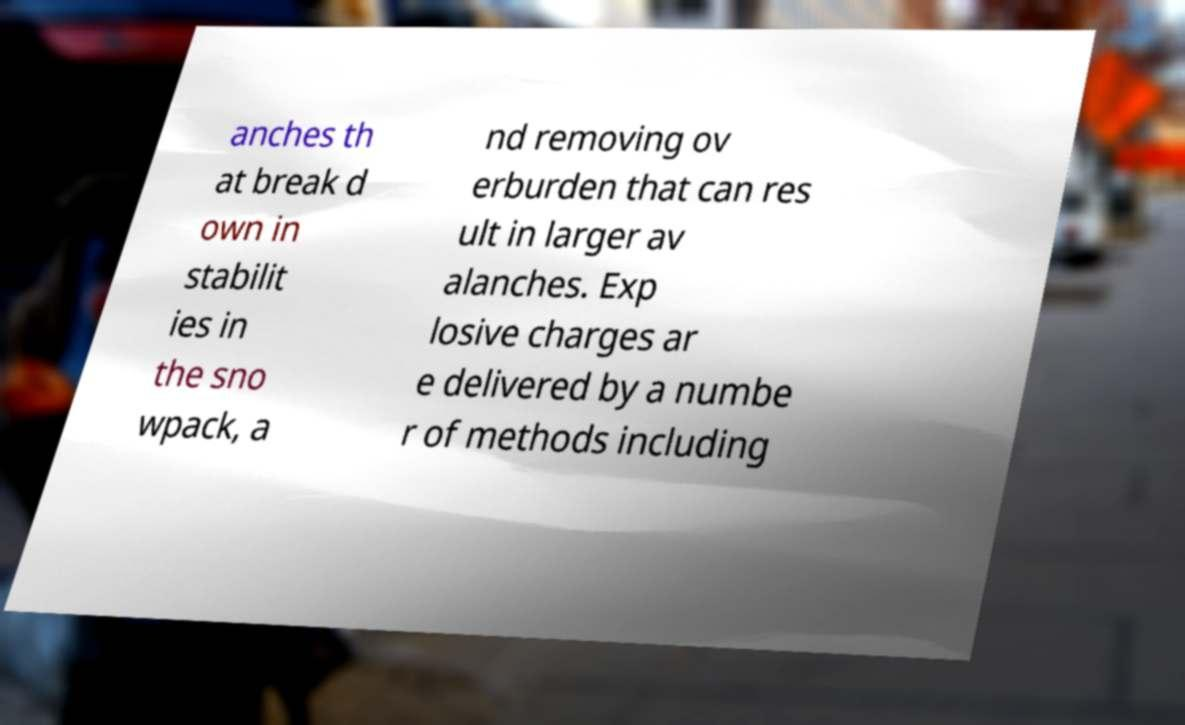For documentation purposes, I need the text within this image transcribed. Could you provide that? anches th at break d own in stabilit ies in the sno wpack, a nd removing ov erburden that can res ult in larger av alanches. Exp losive charges ar e delivered by a numbe r of methods including 